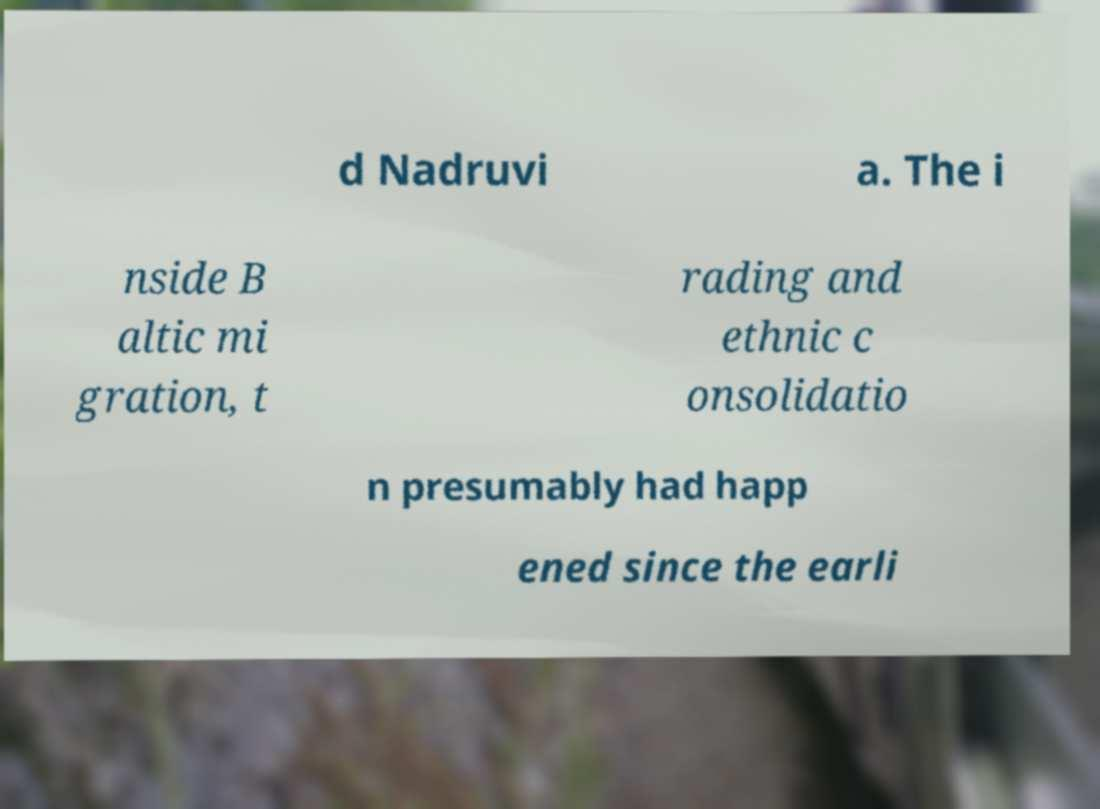There's text embedded in this image that I need extracted. Can you transcribe it verbatim? d Nadruvi a. The i nside B altic mi gration, t rading and ethnic c onsolidatio n presumably had happ ened since the earli 